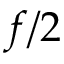<formula> <loc_0><loc_0><loc_500><loc_500>f / 2</formula> 